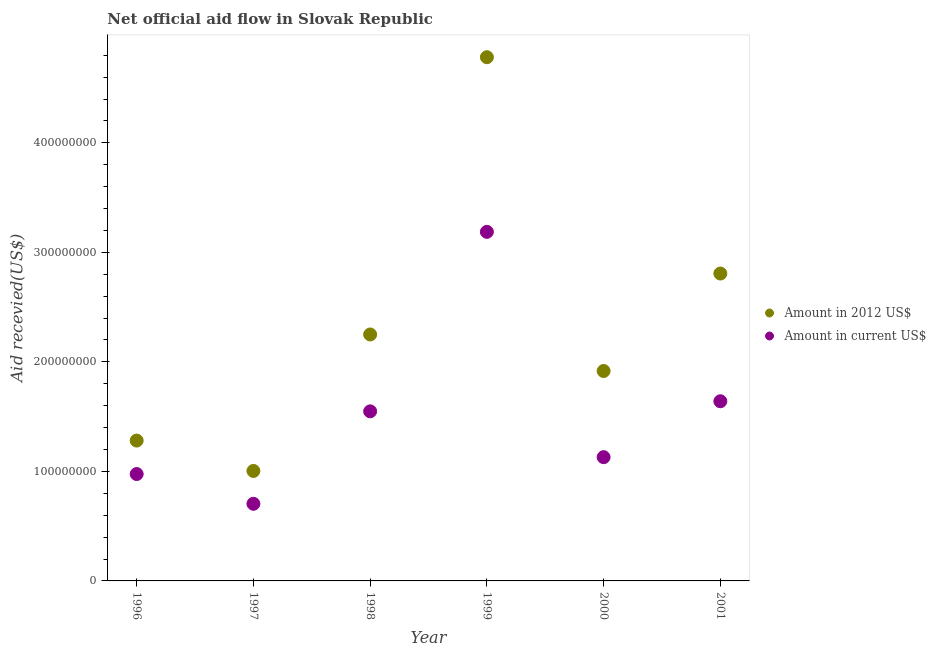What is the amount of aid received(expressed in us$) in 2001?
Provide a succinct answer. 1.64e+08. Across all years, what is the maximum amount of aid received(expressed in 2012 us$)?
Ensure brevity in your answer.  4.78e+08. Across all years, what is the minimum amount of aid received(expressed in us$)?
Offer a very short reply. 7.04e+07. In which year was the amount of aid received(expressed in 2012 us$) maximum?
Provide a short and direct response. 1999. In which year was the amount of aid received(expressed in 2012 us$) minimum?
Provide a succinct answer. 1997. What is the total amount of aid received(expressed in 2012 us$) in the graph?
Give a very brief answer. 1.40e+09. What is the difference between the amount of aid received(expressed in 2012 us$) in 1996 and that in 1998?
Your answer should be compact. -9.69e+07. What is the difference between the amount of aid received(expressed in us$) in 1997 and the amount of aid received(expressed in 2012 us$) in 1996?
Ensure brevity in your answer.  -5.77e+07. What is the average amount of aid received(expressed in us$) per year?
Offer a terse response. 1.53e+08. In the year 1998, what is the difference between the amount of aid received(expressed in us$) and amount of aid received(expressed in 2012 us$)?
Provide a short and direct response. -7.02e+07. In how many years, is the amount of aid received(expressed in us$) greater than 180000000 US$?
Ensure brevity in your answer.  1. What is the ratio of the amount of aid received(expressed in us$) in 1998 to that in 1999?
Make the answer very short. 0.49. Is the difference between the amount of aid received(expressed in us$) in 1999 and 2001 greater than the difference between the amount of aid received(expressed in 2012 us$) in 1999 and 2001?
Make the answer very short. No. What is the difference between the highest and the second highest amount of aid received(expressed in 2012 us$)?
Your answer should be compact. 1.98e+08. What is the difference between the highest and the lowest amount of aid received(expressed in us$)?
Ensure brevity in your answer.  2.48e+08. In how many years, is the amount of aid received(expressed in 2012 us$) greater than the average amount of aid received(expressed in 2012 us$) taken over all years?
Provide a short and direct response. 2. Is the sum of the amount of aid received(expressed in 2012 us$) in 1996 and 1999 greater than the maximum amount of aid received(expressed in us$) across all years?
Provide a short and direct response. Yes. Is the amount of aid received(expressed in us$) strictly less than the amount of aid received(expressed in 2012 us$) over the years?
Offer a terse response. Yes. How many dotlines are there?
Keep it short and to the point. 2. Are the values on the major ticks of Y-axis written in scientific E-notation?
Your answer should be very brief. No. Does the graph contain grids?
Make the answer very short. No. Where does the legend appear in the graph?
Keep it short and to the point. Center right. How many legend labels are there?
Keep it short and to the point. 2. How are the legend labels stacked?
Provide a succinct answer. Vertical. What is the title of the graph?
Ensure brevity in your answer.  Net official aid flow in Slovak Republic. What is the label or title of the Y-axis?
Your response must be concise. Aid recevied(US$). What is the Aid recevied(US$) in Amount in 2012 US$ in 1996?
Offer a terse response. 1.28e+08. What is the Aid recevied(US$) in Amount in current US$ in 1996?
Offer a very short reply. 9.76e+07. What is the Aid recevied(US$) of Amount in 2012 US$ in 1997?
Your response must be concise. 1.00e+08. What is the Aid recevied(US$) in Amount in current US$ in 1997?
Your answer should be compact. 7.04e+07. What is the Aid recevied(US$) in Amount in 2012 US$ in 1998?
Make the answer very short. 2.25e+08. What is the Aid recevied(US$) in Amount in current US$ in 1998?
Provide a succinct answer. 1.55e+08. What is the Aid recevied(US$) of Amount in 2012 US$ in 1999?
Offer a terse response. 4.78e+08. What is the Aid recevied(US$) of Amount in current US$ in 1999?
Keep it short and to the point. 3.19e+08. What is the Aid recevied(US$) of Amount in 2012 US$ in 2000?
Provide a short and direct response. 1.92e+08. What is the Aid recevied(US$) in Amount in current US$ in 2000?
Provide a succinct answer. 1.13e+08. What is the Aid recevied(US$) in Amount in 2012 US$ in 2001?
Ensure brevity in your answer.  2.81e+08. What is the Aid recevied(US$) of Amount in current US$ in 2001?
Your answer should be compact. 1.64e+08. Across all years, what is the maximum Aid recevied(US$) of Amount in 2012 US$?
Make the answer very short. 4.78e+08. Across all years, what is the maximum Aid recevied(US$) of Amount in current US$?
Offer a terse response. 3.19e+08. Across all years, what is the minimum Aid recevied(US$) of Amount in 2012 US$?
Ensure brevity in your answer.  1.00e+08. Across all years, what is the minimum Aid recevied(US$) in Amount in current US$?
Your answer should be very brief. 7.04e+07. What is the total Aid recevied(US$) in Amount in 2012 US$ in the graph?
Ensure brevity in your answer.  1.40e+09. What is the total Aid recevied(US$) of Amount in current US$ in the graph?
Provide a short and direct response. 9.19e+08. What is the difference between the Aid recevied(US$) of Amount in 2012 US$ in 1996 and that in 1997?
Your response must be concise. 2.77e+07. What is the difference between the Aid recevied(US$) of Amount in current US$ in 1996 and that in 1997?
Give a very brief answer. 2.72e+07. What is the difference between the Aid recevied(US$) of Amount in 2012 US$ in 1996 and that in 1998?
Your answer should be very brief. -9.69e+07. What is the difference between the Aid recevied(US$) of Amount in current US$ in 1996 and that in 1998?
Provide a succinct answer. -5.72e+07. What is the difference between the Aid recevied(US$) of Amount in 2012 US$ in 1996 and that in 1999?
Your answer should be compact. -3.50e+08. What is the difference between the Aid recevied(US$) of Amount in current US$ in 1996 and that in 1999?
Ensure brevity in your answer.  -2.21e+08. What is the difference between the Aid recevied(US$) of Amount in 2012 US$ in 1996 and that in 2000?
Offer a very short reply. -6.35e+07. What is the difference between the Aid recevied(US$) of Amount in current US$ in 1996 and that in 2000?
Offer a terse response. -1.54e+07. What is the difference between the Aid recevied(US$) of Amount in 2012 US$ in 1996 and that in 2001?
Provide a succinct answer. -1.53e+08. What is the difference between the Aid recevied(US$) in Amount in current US$ in 1996 and that in 2001?
Your response must be concise. -6.64e+07. What is the difference between the Aid recevied(US$) of Amount in 2012 US$ in 1997 and that in 1998?
Provide a short and direct response. -1.25e+08. What is the difference between the Aid recevied(US$) in Amount in current US$ in 1997 and that in 1998?
Make the answer very short. -8.44e+07. What is the difference between the Aid recevied(US$) in Amount in 2012 US$ in 1997 and that in 1999?
Keep it short and to the point. -3.78e+08. What is the difference between the Aid recevied(US$) of Amount in current US$ in 1997 and that in 1999?
Give a very brief answer. -2.48e+08. What is the difference between the Aid recevied(US$) of Amount in 2012 US$ in 1997 and that in 2000?
Your answer should be compact. -9.12e+07. What is the difference between the Aid recevied(US$) in Amount in current US$ in 1997 and that in 2000?
Provide a succinct answer. -4.26e+07. What is the difference between the Aid recevied(US$) in Amount in 2012 US$ in 1997 and that in 2001?
Your response must be concise. -1.80e+08. What is the difference between the Aid recevied(US$) of Amount in current US$ in 1997 and that in 2001?
Offer a terse response. -9.36e+07. What is the difference between the Aid recevied(US$) of Amount in 2012 US$ in 1998 and that in 1999?
Provide a short and direct response. -2.53e+08. What is the difference between the Aid recevied(US$) of Amount in current US$ in 1998 and that in 1999?
Your answer should be very brief. -1.64e+08. What is the difference between the Aid recevied(US$) of Amount in 2012 US$ in 1998 and that in 2000?
Provide a succinct answer. 3.33e+07. What is the difference between the Aid recevied(US$) of Amount in current US$ in 1998 and that in 2000?
Offer a terse response. 4.18e+07. What is the difference between the Aid recevied(US$) of Amount in 2012 US$ in 1998 and that in 2001?
Your answer should be very brief. -5.56e+07. What is the difference between the Aid recevied(US$) in Amount in current US$ in 1998 and that in 2001?
Offer a terse response. -9.22e+06. What is the difference between the Aid recevied(US$) in Amount in 2012 US$ in 1999 and that in 2000?
Provide a succinct answer. 2.86e+08. What is the difference between the Aid recevied(US$) in Amount in current US$ in 1999 and that in 2000?
Provide a succinct answer. 2.06e+08. What is the difference between the Aid recevied(US$) in Amount in 2012 US$ in 1999 and that in 2001?
Offer a terse response. 1.98e+08. What is the difference between the Aid recevied(US$) of Amount in current US$ in 1999 and that in 2001?
Your answer should be very brief. 1.55e+08. What is the difference between the Aid recevied(US$) in Amount in 2012 US$ in 2000 and that in 2001?
Your response must be concise. -8.90e+07. What is the difference between the Aid recevied(US$) in Amount in current US$ in 2000 and that in 2001?
Your response must be concise. -5.10e+07. What is the difference between the Aid recevied(US$) in Amount in 2012 US$ in 1996 and the Aid recevied(US$) in Amount in current US$ in 1997?
Ensure brevity in your answer.  5.77e+07. What is the difference between the Aid recevied(US$) of Amount in 2012 US$ in 1996 and the Aid recevied(US$) of Amount in current US$ in 1998?
Keep it short and to the point. -2.67e+07. What is the difference between the Aid recevied(US$) of Amount in 2012 US$ in 1996 and the Aid recevied(US$) of Amount in current US$ in 1999?
Provide a short and direct response. -1.91e+08. What is the difference between the Aid recevied(US$) in Amount in 2012 US$ in 1996 and the Aid recevied(US$) in Amount in current US$ in 2000?
Offer a very short reply. 1.52e+07. What is the difference between the Aid recevied(US$) of Amount in 2012 US$ in 1996 and the Aid recevied(US$) of Amount in current US$ in 2001?
Offer a very short reply. -3.59e+07. What is the difference between the Aid recevied(US$) in Amount in 2012 US$ in 1997 and the Aid recevied(US$) in Amount in current US$ in 1998?
Provide a succinct answer. -5.44e+07. What is the difference between the Aid recevied(US$) in Amount in 2012 US$ in 1997 and the Aid recevied(US$) in Amount in current US$ in 1999?
Your answer should be very brief. -2.18e+08. What is the difference between the Aid recevied(US$) of Amount in 2012 US$ in 1997 and the Aid recevied(US$) of Amount in current US$ in 2000?
Give a very brief answer. -1.26e+07. What is the difference between the Aid recevied(US$) in Amount in 2012 US$ in 1997 and the Aid recevied(US$) in Amount in current US$ in 2001?
Ensure brevity in your answer.  -6.36e+07. What is the difference between the Aid recevied(US$) of Amount in 2012 US$ in 1998 and the Aid recevied(US$) of Amount in current US$ in 1999?
Keep it short and to the point. -9.37e+07. What is the difference between the Aid recevied(US$) in Amount in 2012 US$ in 1998 and the Aid recevied(US$) in Amount in current US$ in 2000?
Provide a short and direct response. 1.12e+08. What is the difference between the Aid recevied(US$) of Amount in 2012 US$ in 1998 and the Aid recevied(US$) of Amount in current US$ in 2001?
Your answer should be very brief. 6.10e+07. What is the difference between the Aid recevied(US$) of Amount in 2012 US$ in 1999 and the Aid recevied(US$) of Amount in current US$ in 2000?
Ensure brevity in your answer.  3.65e+08. What is the difference between the Aid recevied(US$) of Amount in 2012 US$ in 1999 and the Aid recevied(US$) of Amount in current US$ in 2001?
Ensure brevity in your answer.  3.14e+08. What is the difference between the Aid recevied(US$) of Amount in 2012 US$ in 2000 and the Aid recevied(US$) of Amount in current US$ in 2001?
Keep it short and to the point. 2.76e+07. What is the average Aid recevied(US$) of Amount in 2012 US$ per year?
Offer a terse response. 2.34e+08. What is the average Aid recevied(US$) of Amount in current US$ per year?
Keep it short and to the point. 1.53e+08. In the year 1996, what is the difference between the Aid recevied(US$) in Amount in 2012 US$ and Aid recevied(US$) in Amount in current US$?
Offer a terse response. 3.06e+07. In the year 1997, what is the difference between the Aid recevied(US$) of Amount in 2012 US$ and Aid recevied(US$) of Amount in current US$?
Offer a terse response. 3.00e+07. In the year 1998, what is the difference between the Aid recevied(US$) of Amount in 2012 US$ and Aid recevied(US$) of Amount in current US$?
Provide a short and direct response. 7.02e+07. In the year 1999, what is the difference between the Aid recevied(US$) in Amount in 2012 US$ and Aid recevied(US$) in Amount in current US$?
Your response must be concise. 1.59e+08. In the year 2000, what is the difference between the Aid recevied(US$) in Amount in 2012 US$ and Aid recevied(US$) in Amount in current US$?
Keep it short and to the point. 7.87e+07. In the year 2001, what is the difference between the Aid recevied(US$) of Amount in 2012 US$ and Aid recevied(US$) of Amount in current US$?
Your response must be concise. 1.17e+08. What is the ratio of the Aid recevied(US$) of Amount in 2012 US$ in 1996 to that in 1997?
Provide a succinct answer. 1.28. What is the ratio of the Aid recevied(US$) of Amount in current US$ in 1996 to that in 1997?
Your answer should be very brief. 1.39. What is the ratio of the Aid recevied(US$) in Amount in 2012 US$ in 1996 to that in 1998?
Provide a short and direct response. 0.57. What is the ratio of the Aid recevied(US$) of Amount in current US$ in 1996 to that in 1998?
Make the answer very short. 0.63. What is the ratio of the Aid recevied(US$) in Amount in 2012 US$ in 1996 to that in 1999?
Give a very brief answer. 0.27. What is the ratio of the Aid recevied(US$) in Amount in current US$ in 1996 to that in 1999?
Provide a short and direct response. 0.31. What is the ratio of the Aid recevied(US$) in Amount in 2012 US$ in 1996 to that in 2000?
Your answer should be compact. 0.67. What is the ratio of the Aid recevied(US$) in Amount in current US$ in 1996 to that in 2000?
Keep it short and to the point. 0.86. What is the ratio of the Aid recevied(US$) in Amount in 2012 US$ in 1996 to that in 2001?
Offer a very short reply. 0.46. What is the ratio of the Aid recevied(US$) of Amount in current US$ in 1996 to that in 2001?
Offer a terse response. 0.59. What is the ratio of the Aid recevied(US$) of Amount in 2012 US$ in 1997 to that in 1998?
Give a very brief answer. 0.45. What is the ratio of the Aid recevied(US$) in Amount in current US$ in 1997 to that in 1998?
Ensure brevity in your answer.  0.45. What is the ratio of the Aid recevied(US$) of Amount in 2012 US$ in 1997 to that in 1999?
Your answer should be compact. 0.21. What is the ratio of the Aid recevied(US$) in Amount in current US$ in 1997 to that in 1999?
Your answer should be very brief. 0.22. What is the ratio of the Aid recevied(US$) of Amount in 2012 US$ in 1997 to that in 2000?
Provide a short and direct response. 0.52. What is the ratio of the Aid recevied(US$) in Amount in current US$ in 1997 to that in 2000?
Provide a short and direct response. 0.62. What is the ratio of the Aid recevied(US$) of Amount in 2012 US$ in 1997 to that in 2001?
Ensure brevity in your answer.  0.36. What is the ratio of the Aid recevied(US$) in Amount in current US$ in 1997 to that in 2001?
Offer a terse response. 0.43. What is the ratio of the Aid recevied(US$) of Amount in 2012 US$ in 1998 to that in 1999?
Your answer should be compact. 0.47. What is the ratio of the Aid recevied(US$) in Amount in current US$ in 1998 to that in 1999?
Give a very brief answer. 0.49. What is the ratio of the Aid recevied(US$) in Amount in 2012 US$ in 1998 to that in 2000?
Keep it short and to the point. 1.17. What is the ratio of the Aid recevied(US$) in Amount in current US$ in 1998 to that in 2000?
Offer a terse response. 1.37. What is the ratio of the Aid recevied(US$) of Amount in 2012 US$ in 1998 to that in 2001?
Give a very brief answer. 0.8. What is the ratio of the Aid recevied(US$) in Amount in current US$ in 1998 to that in 2001?
Make the answer very short. 0.94. What is the ratio of the Aid recevied(US$) in Amount in 2012 US$ in 1999 to that in 2000?
Keep it short and to the point. 2.49. What is the ratio of the Aid recevied(US$) of Amount in current US$ in 1999 to that in 2000?
Your answer should be compact. 2.82. What is the ratio of the Aid recevied(US$) in Amount in 2012 US$ in 1999 to that in 2001?
Keep it short and to the point. 1.7. What is the ratio of the Aid recevied(US$) in Amount in current US$ in 1999 to that in 2001?
Provide a succinct answer. 1.94. What is the ratio of the Aid recevied(US$) in Amount in 2012 US$ in 2000 to that in 2001?
Give a very brief answer. 0.68. What is the ratio of the Aid recevied(US$) of Amount in current US$ in 2000 to that in 2001?
Keep it short and to the point. 0.69. What is the difference between the highest and the second highest Aid recevied(US$) of Amount in 2012 US$?
Give a very brief answer. 1.98e+08. What is the difference between the highest and the second highest Aid recevied(US$) in Amount in current US$?
Give a very brief answer. 1.55e+08. What is the difference between the highest and the lowest Aid recevied(US$) in Amount in 2012 US$?
Offer a very short reply. 3.78e+08. What is the difference between the highest and the lowest Aid recevied(US$) in Amount in current US$?
Your answer should be very brief. 2.48e+08. 